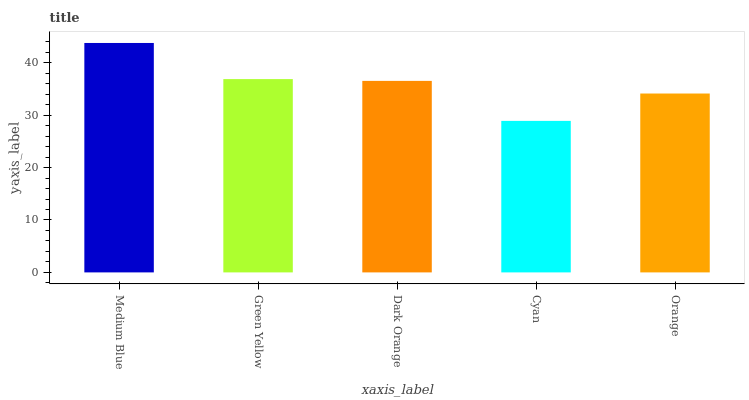Is Cyan the minimum?
Answer yes or no. Yes. Is Medium Blue the maximum?
Answer yes or no. Yes. Is Green Yellow the minimum?
Answer yes or no. No. Is Green Yellow the maximum?
Answer yes or no. No. Is Medium Blue greater than Green Yellow?
Answer yes or no. Yes. Is Green Yellow less than Medium Blue?
Answer yes or no. Yes. Is Green Yellow greater than Medium Blue?
Answer yes or no. No. Is Medium Blue less than Green Yellow?
Answer yes or no. No. Is Dark Orange the high median?
Answer yes or no. Yes. Is Dark Orange the low median?
Answer yes or no. Yes. Is Cyan the high median?
Answer yes or no. No. Is Cyan the low median?
Answer yes or no. No. 